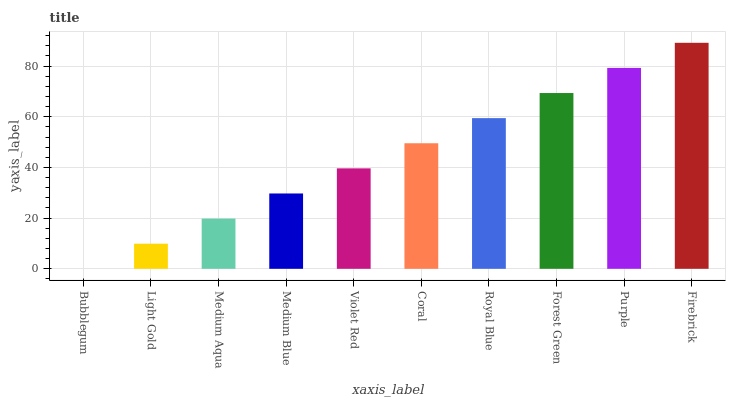Is Light Gold the minimum?
Answer yes or no. No. Is Light Gold the maximum?
Answer yes or no. No. Is Light Gold greater than Bubblegum?
Answer yes or no. Yes. Is Bubblegum less than Light Gold?
Answer yes or no. Yes. Is Bubblegum greater than Light Gold?
Answer yes or no. No. Is Light Gold less than Bubblegum?
Answer yes or no. No. Is Coral the high median?
Answer yes or no. Yes. Is Violet Red the low median?
Answer yes or no. Yes. Is Violet Red the high median?
Answer yes or no. No. Is Medium Aqua the low median?
Answer yes or no. No. 